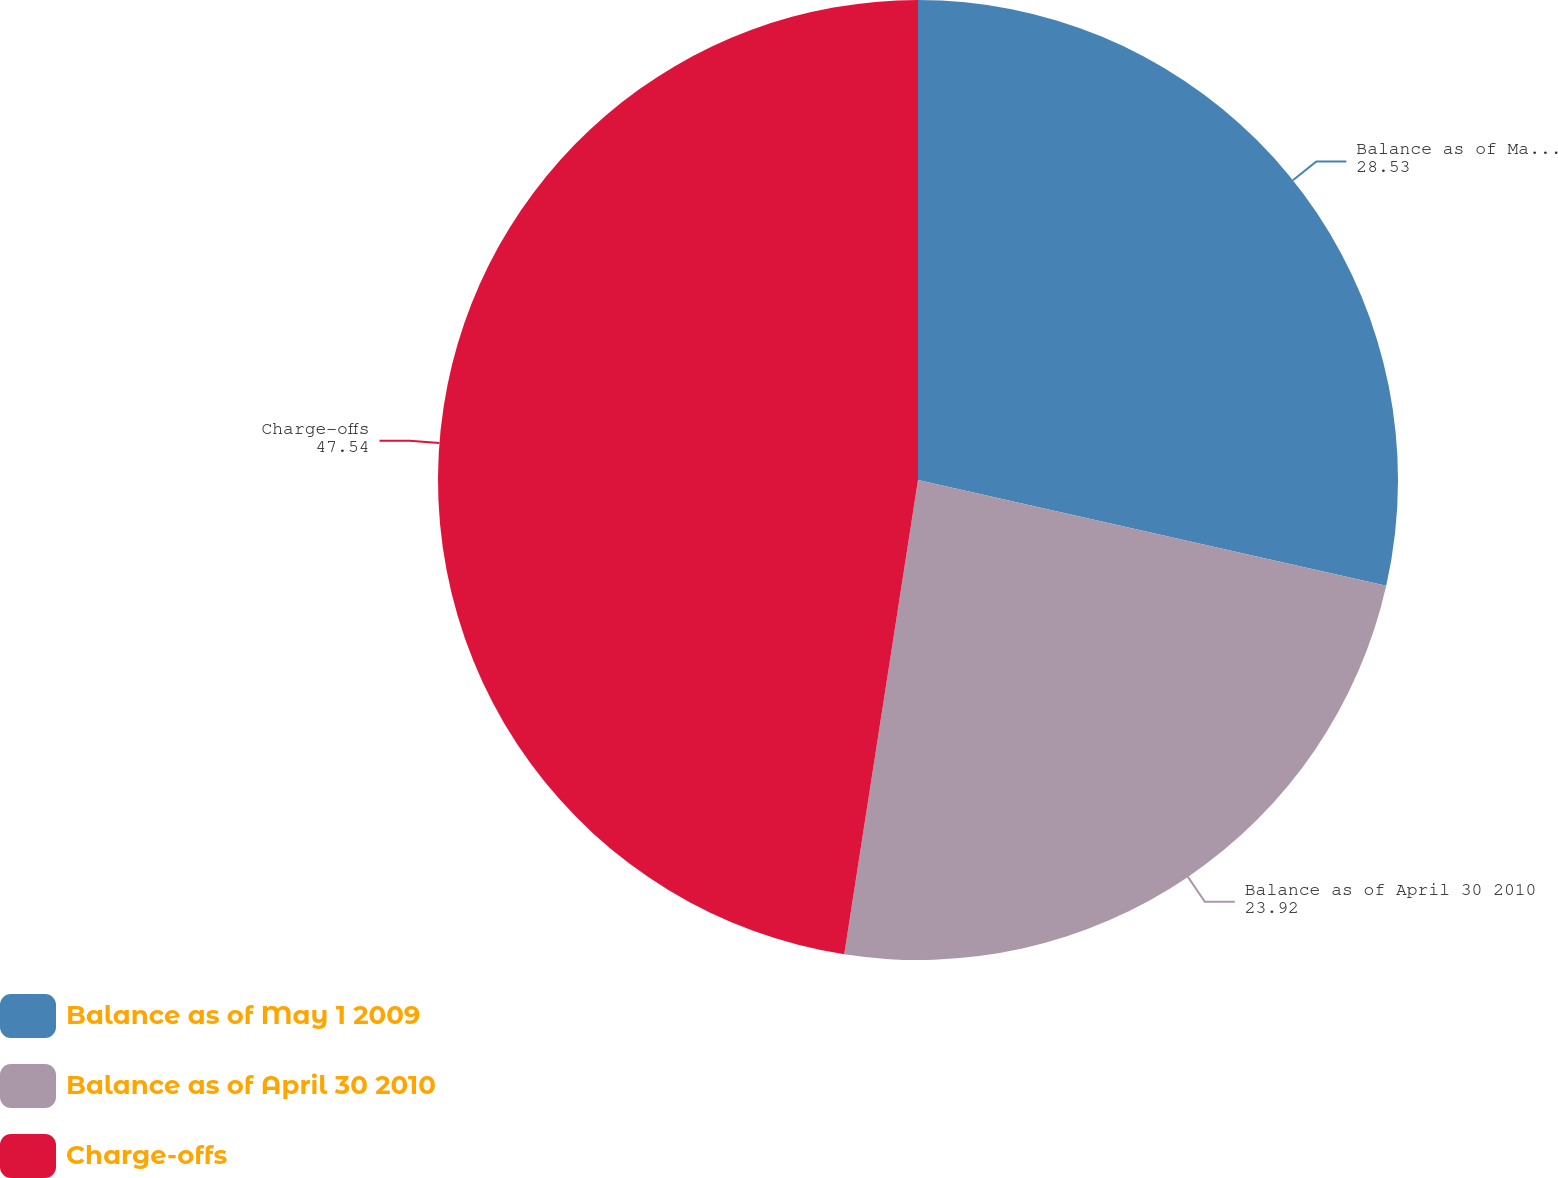<chart> <loc_0><loc_0><loc_500><loc_500><pie_chart><fcel>Balance as of May 1 2009<fcel>Balance as of April 30 2010<fcel>Charge-offs<nl><fcel>28.53%<fcel>23.92%<fcel>47.54%<nl></chart> 